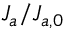<formula> <loc_0><loc_0><loc_500><loc_500>J _ { a } / J _ { a , 0 }</formula> 